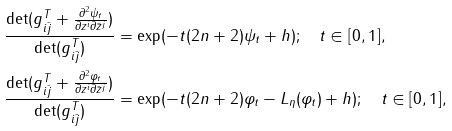Convert formula to latex. <formula><loc_0><loc_0><loc_500><loc_500>\frac { \det ( g ^ { T } _ { i \bar { j } } + \frac { \partial ^ { 2 } \psi _ { t } } { \partial z ^ { i } \partial \bar { z } ^ { j } } ) } { \det ( g ^ { T } _ { i \bar { j } } ) } & = \exp ( - t ( 2 n + 2 ) \psi _ { t } + h ) ; \quad t \in [ 0 , 1 ] , \\ \frac { \det ( g ^ { T } _ { i \bar { j } } + \frac { \partial ^ { 2 } \varphi _ { t } } { \partial z ^ { i } \partial \bar { z } ^ { j } } ) } { \det ( g ^ { T } _ { i \bar { j } } ) } & = \exp ( - t ( 2 n + 2 ) \varphi _ { t } - L _ { \eta } ( \varphi _ { t } ) + h ) ; \quad t \in [ 0 , 1 ] ,</formula> 